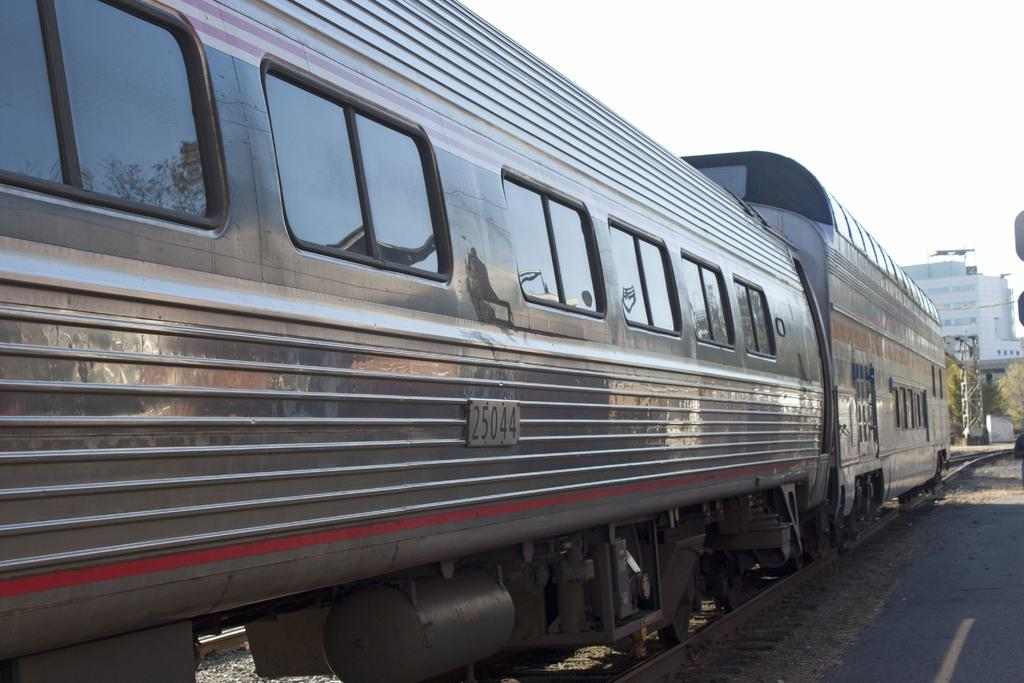What is the main subject in the foreground of the picture? There is a train in the foreground of the picture. What can be seen in the background towards the right? There are trees and buildings in the background towards the right. What is present on the right side of the image? There are stones and a road on the right side of the image. How would you describe the weather in the image? The sky is sunny, indicating a clear and bright day. Where is the basket of fruits located in the image? There is no basket of fruits present in the image. What type of pen can be seen being used by the train conductor in the image? There is no pen or train conductor visible in the image. 